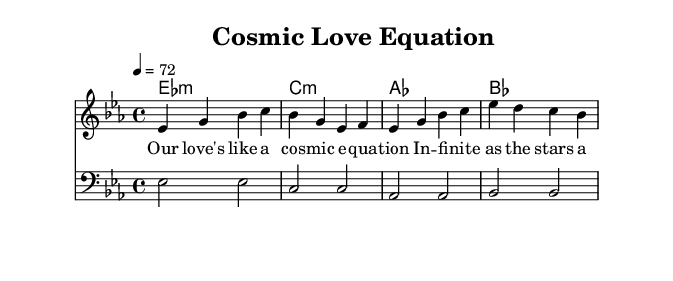What is the key signature of this music? The key signature is E flat major, which is indicated by three flats (B flat, E flat, and A flat). This is the first thing to notice at the beginning of the staff.
Answer: E flat major What is the time signature of the piece? The time signature is 4/4, which means there are four beats in each measure and the quarter note gets one beat. This is indicated at the beginning of the staff.
Answer: 4/4 What is the tempo marking for this piece? The tempo marking is 72 beats per minute. This is shown at the beginning of the score as "4 = 72." This tells the performer how fast to play the piece.
Answer: 72 How many measures are there in the melody section? There are 8 measures in the melody section as counted from the melody notes and the shape of the music, each separated by vertical bar lines.
Answer: 8 Which chord appears on the first beat of the first measure? The first chord appearing on the first beat of the first measure is E flat minor. This can be identified from the chord symbol above the staff.
Answer: E flat minor What lyrical theme is prevalent in the lyrics provided? The lyrical theme is love and cosmic concepts, which can be inferred from the text mentioning "cosmic equation" and "stars above," suggesting a connection between love and the universe.
Answer: Love and cosmic concepts How does the bass line relate to the melody in the context of R&B? The bass line supports the melody by providing a foundational harmony. In R&B, the bass often emphasizes the root notes of the chords to provide groove and depth to the soulful melody. This relationship can be understood by analyzing how the bass notes correspond with the harmonic structure above it.
Answer: Foundation and groove 